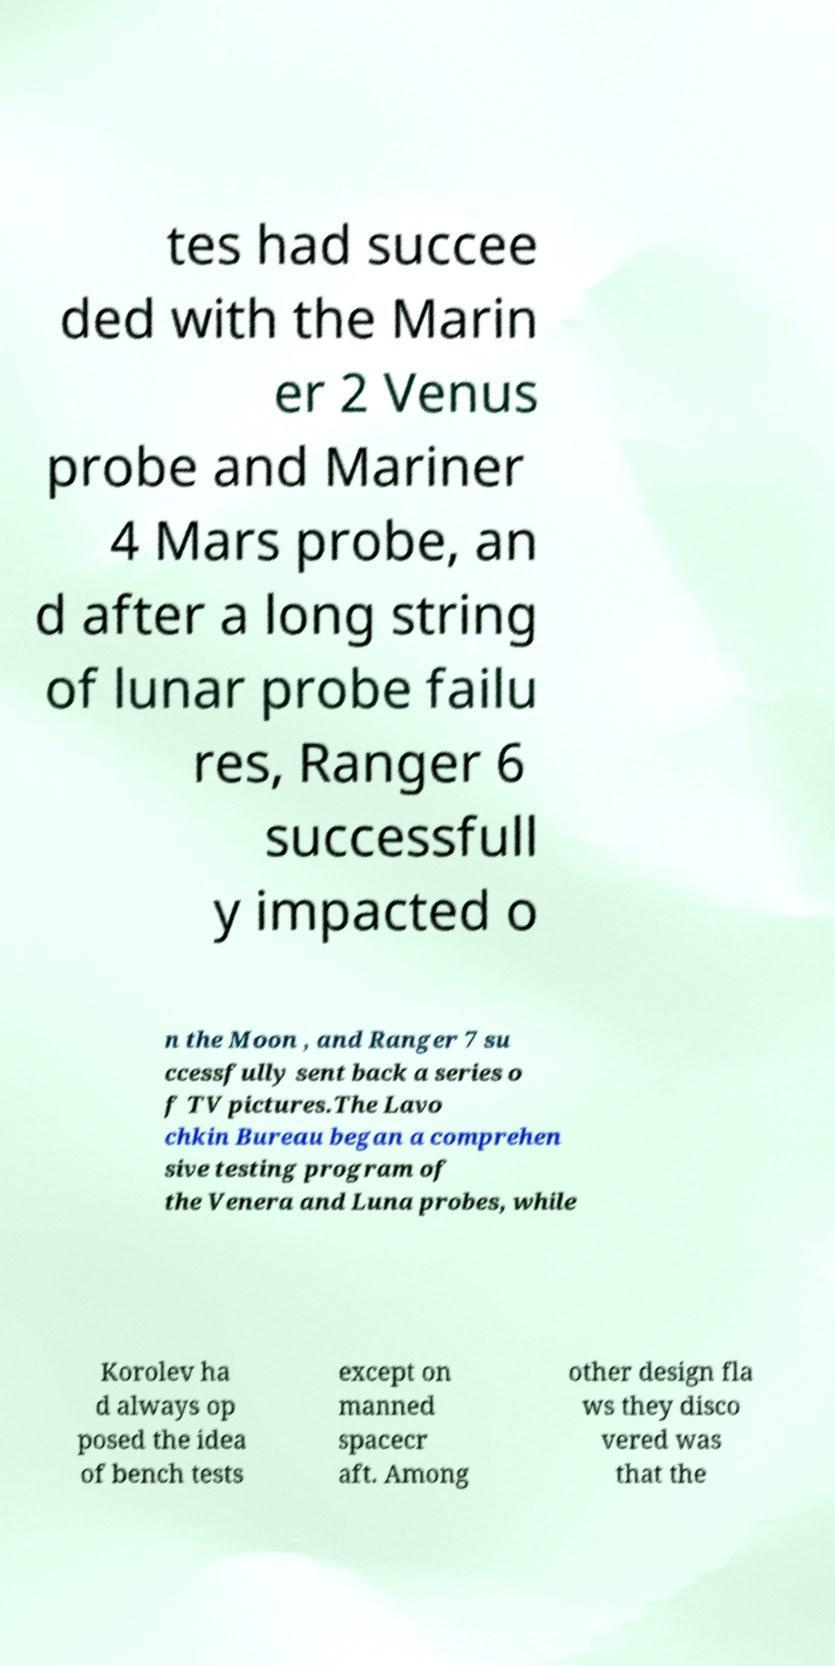Please read and relay the text visible in this image. What does it say? tes had succee ded with the Marin er 2 Venus probe and Mariner 4 Mars probe, an d after a long string of lunar probe failu res, Ranger 6 successfull y impacted o n the Moon , and Ranger 7 su ccessfully sent back a series o f TV pictures.The Lavo chkin Bureau began a comprehen sive testing program of the Venera and Luna probes, while Korolev ha d always op posed the idea of bench tests except on manned spacecr aft. Among other design fla ws they disco vered was that the 